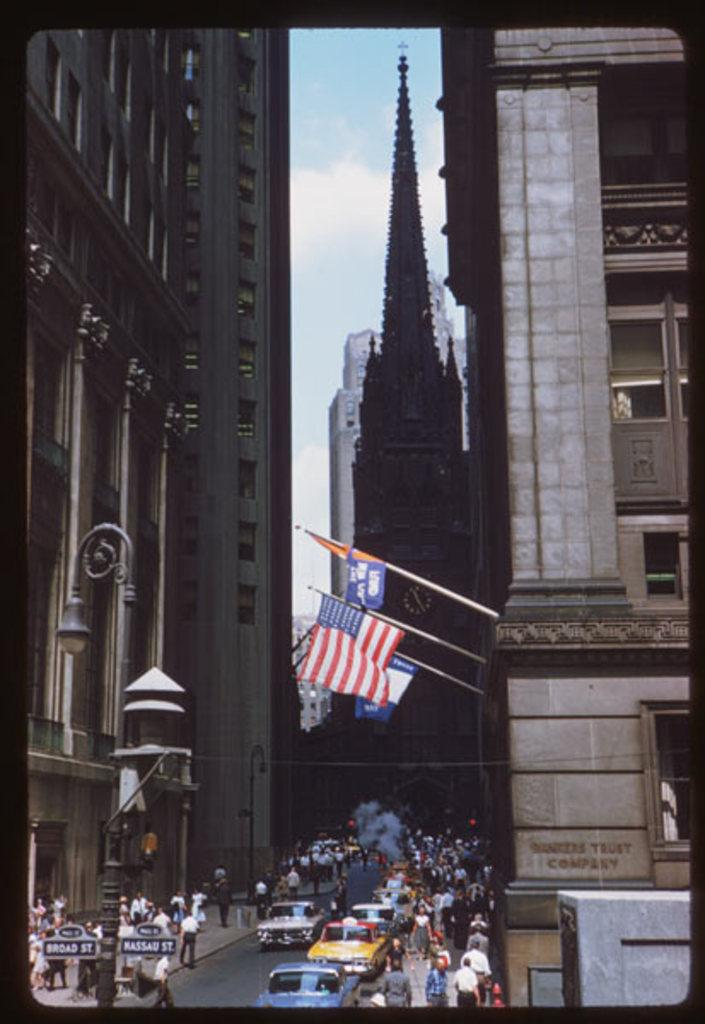What type of image is being described? The image is an edited picture. What can be seen on the road in the image? There are vehicles on the road in the image. Who or what is present in the group in the image? There is a group of people in the image. What objects are associated with the flags in the image? There are flags with poles in the image. What type of structures are visible in the image? There are buildings in the image. What is visible in the background of the image? The sky is visible in the background of the image. What type of insurance policy is being discussed by the lizards in the image? There are no lizards present in the image, and therefore no discussion about insurance policies can be observed. 